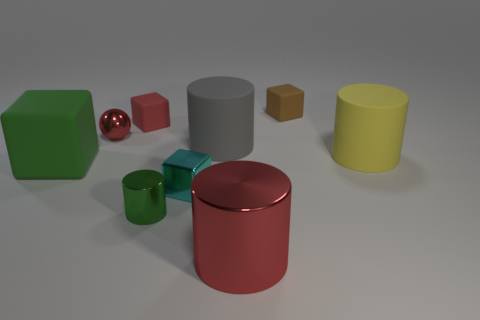Subtract all big yellow rubber cylinders. How many cylinders are left? 3 Subtract all green cylinders. How many cylinders are left? 3 Subtract all cylinders. How many objects are left? 5 Add 1 green rubber things. How many objects exist? 10 Subtract all yellow cylinders. Subtract all yellow balls. How many cylinders are left? 3 Subtract all yellow blocks. How many gray cylinders are left? 1 Subtract all green metallic objects. Subtract all small shiny things. How many objects are left? 5 Add 5 large green things. How many large green things are left? 6 Add 6 yellow objects. How many yellow objects exist? 7 Subtract 0 cyan balls. How many objects are left? 9 